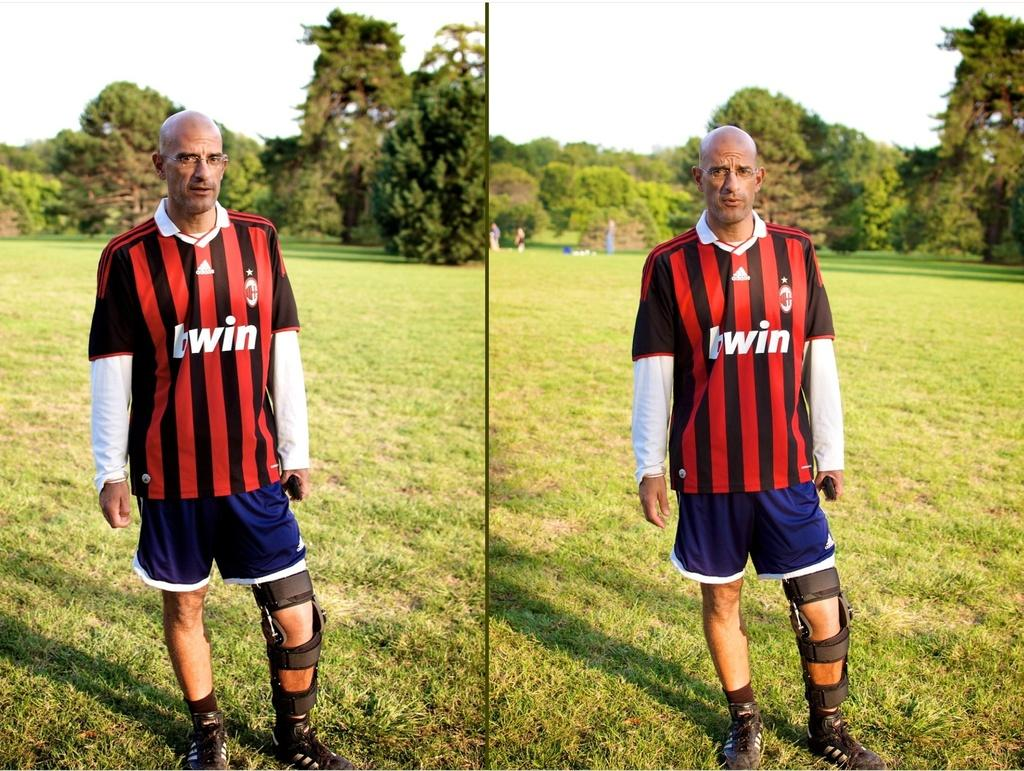<image>
Summarize the visual content of the image. A man in a shirt that says bwin on it stands in an open field. 